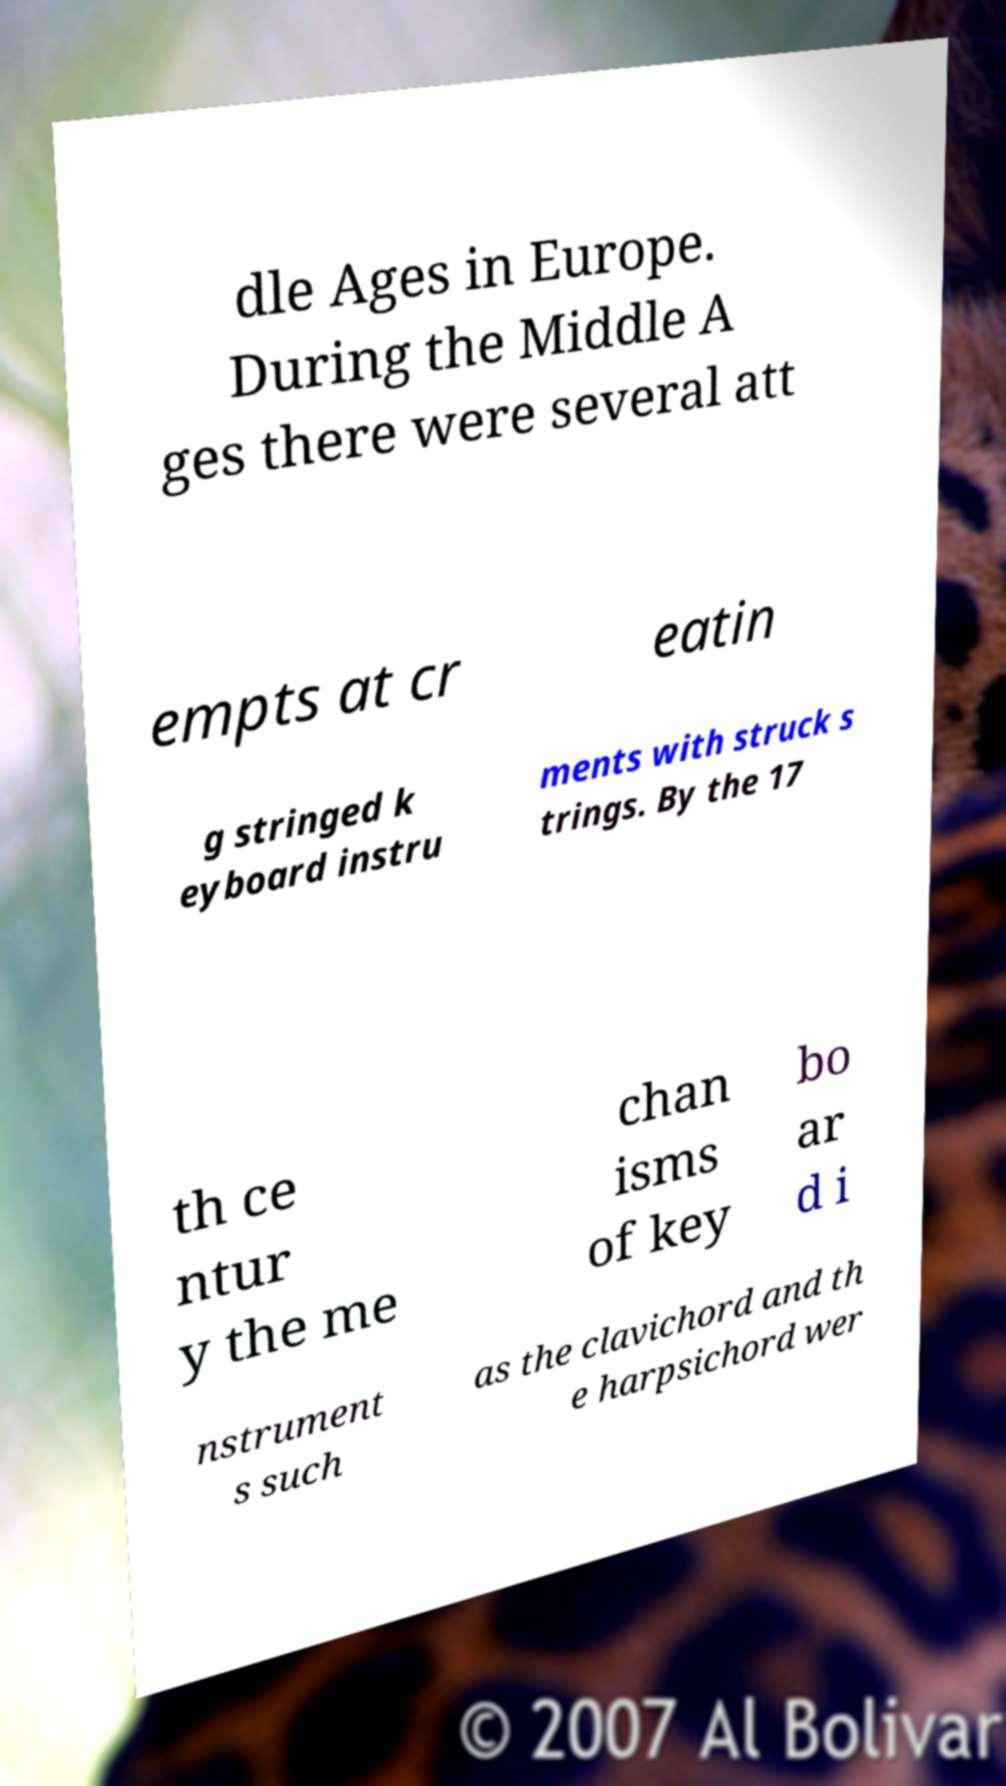Can you read and provide the text displayed in the image?This photo seems to have some interesting text. Can you extract and type it out for me? dle Ages in Europe. During the Middle A ges there were several att empts at cr eatin g stringed k eyboard instru ments with struck s trings. By the 17 th ce ntur y the me chan isms of key bo ar d i nstrument s such as the clavichord and th e harpsichord wer 